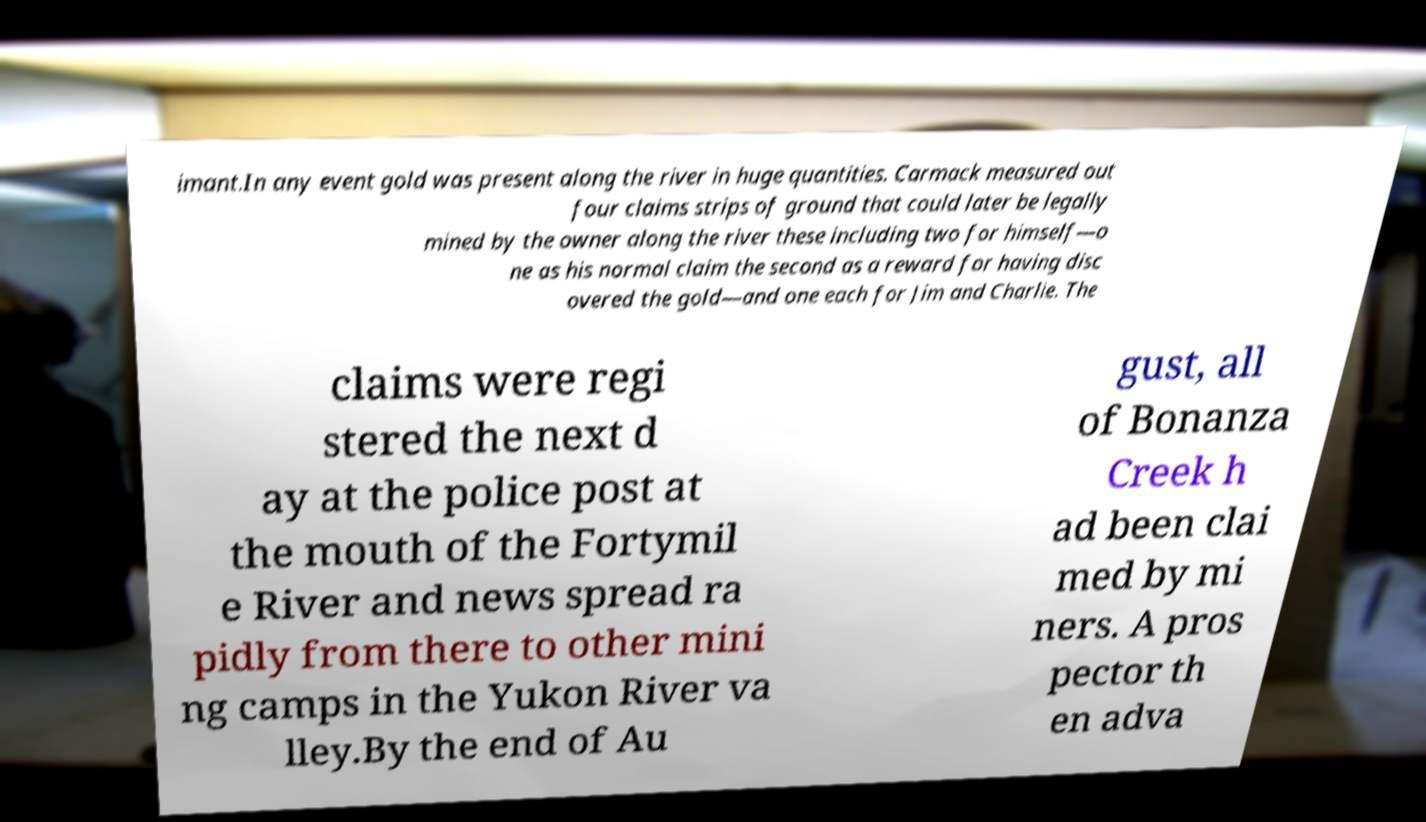Please read and relay the text visible in this image. What does it say? imant.In any event gold was present along the river in huge quantities. Carmack measured out four claims strips of ground that could later be legally mined by the owner along the river these including two for himself—o ne as his normal claim the second as a reward for having disc overed the gold—and one each for Jim and Charlie. The claims were regi stered the next d ay at the police post at the mouth of the Fortymil e River and news spread ra pidly from there to other mini ng camps in the Yukon River va lley.By the end of Au gust, all of Bonanza Creek h ad been clai med by mi ners. A pros pector th en adva 